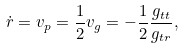Convert formula to latex. <formula><loc_0><loc_0><loc_500><loc_500>\dot { r } = v _ { p } = \frac { 1 } { 2 } v _ { g } = - \frac { 1 } { 2 } \frac { g _ { t t } } { g _ { t r } } ,</formula> 